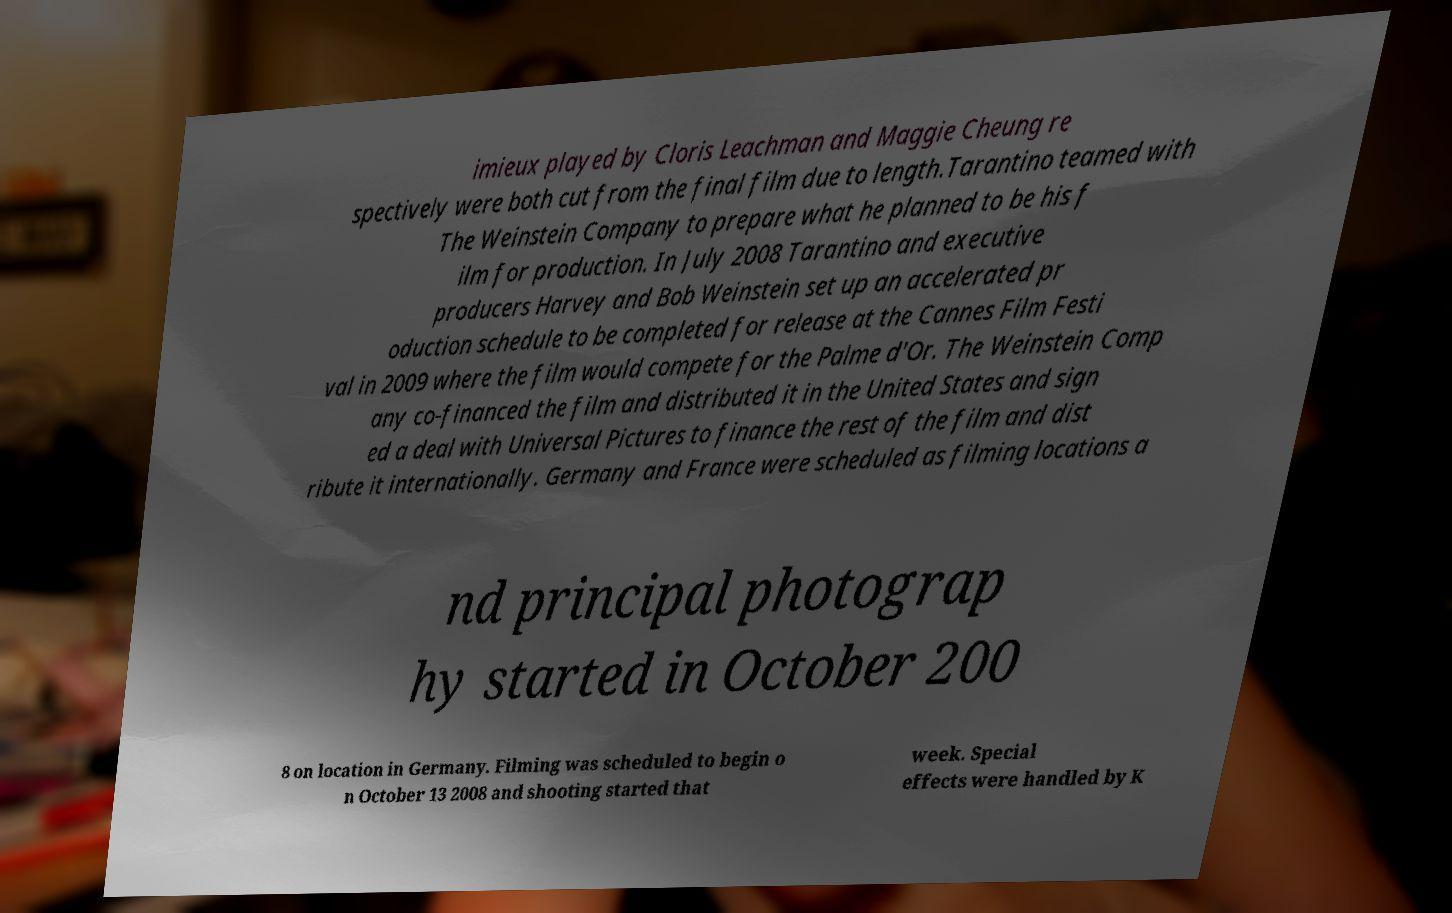Could you assist in decoding the text presented in this image and type it out clearly? imieux played by Cloris Leachman and Maggie Cheung re spectively were both cut from the final film due to length.Tarantino teamed with The Weinstein Company to prepare what he planned to be his f ilm for production. In July 2008 Tarantino and executive producers Harvey and Bob Weinstein set up an accelerated pr oduction schedule to be completed for release at the Cannes Film Festi val in 2009 where the film would compete for the Palme d'Or. The Weinstein Comp any co-financed the film and distributed it in the United States and sign ed a deal with Universal Pictures to finance the rest of the film and dist ribute it internationally. Germany and France were scheduled as filming locations a nd principal photograp hy started in October 200 8 on location in Germany. Filming was scheduled to begin o n October 13 2008 and shooting started that week. Special effects were handled by K 